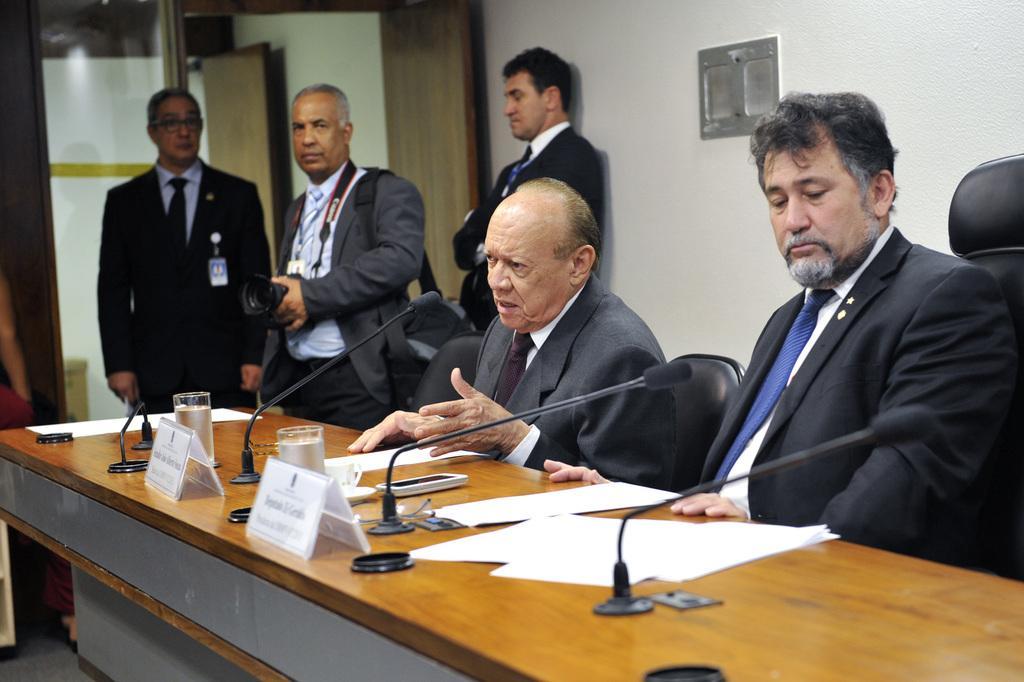In one or two sentences, can you explain what this image depicts? There are two men sitting on the chairs at the table. On the table we can see papers, microphones, mobile, cup on a saucer, water glasses and tags. In the background there are few persons standing, object on the wall, doors, glass door and a man is holding a camera in his hands and carrying a bag on his shoulder. 